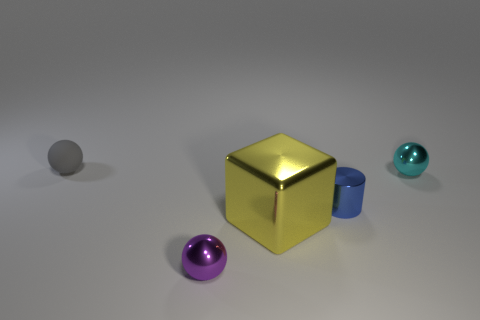How many purple objects have the same shape as the tiny gray matte thing?
Ensure brevity in your answer.  1. How big is the yellow thing in front of the ball that is on the right side of the small shiny object on the left side of the big yellow metal object?
Provide a succinct answer. Large. Are there more rubber things in front of the metal cylinder than small gray spheres?
Provide a short and direct response. No. Are there any large cyan rubber objects?
Offer a terse response. No. What number of cyan balls have the same size as the blue metallic object?
Your answer should be compact. 1. Are there more small metal objects right of the blue metallic cylinder than rubber spheres in front of the rubber thing?
Ensure brevity in your answer.  Yes. What material is the gray object that is the same size as the purple shiny ball?
Make the answer very short. Rubber. What shape is the small purple metallic thing?
Your answer should be compact. Sphere. How many brown objects are either tiny things or blocks?
Offer a very short reply. 0. What size is the blue cylinder that is the same material as the large yellow thing?
Your response must be concise. Small. 